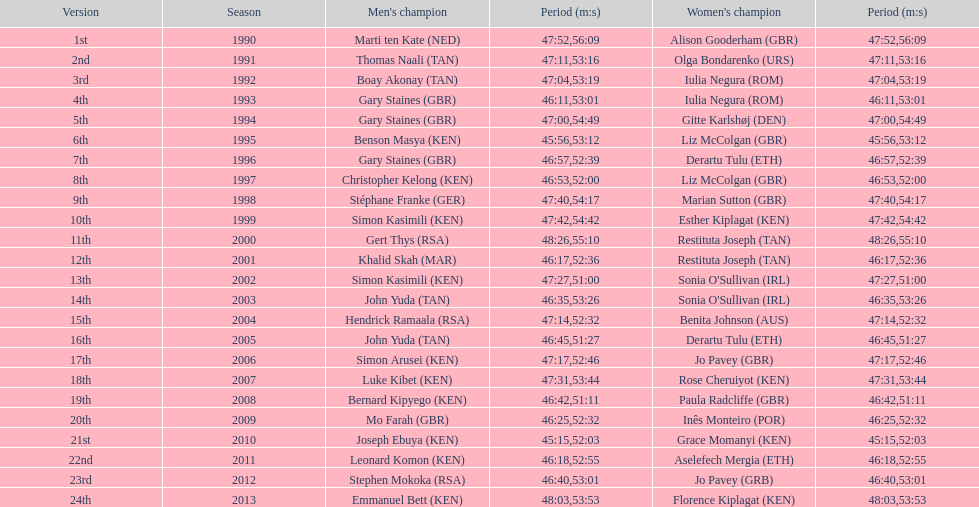Home many times did a single country win both the men's and women's bupa great south run? 4. 